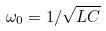<formula> <loc_0><loc_0><loc_500><loc_500>\omega _ { 0 } = 1 / \sqrt { L C }</formula> 